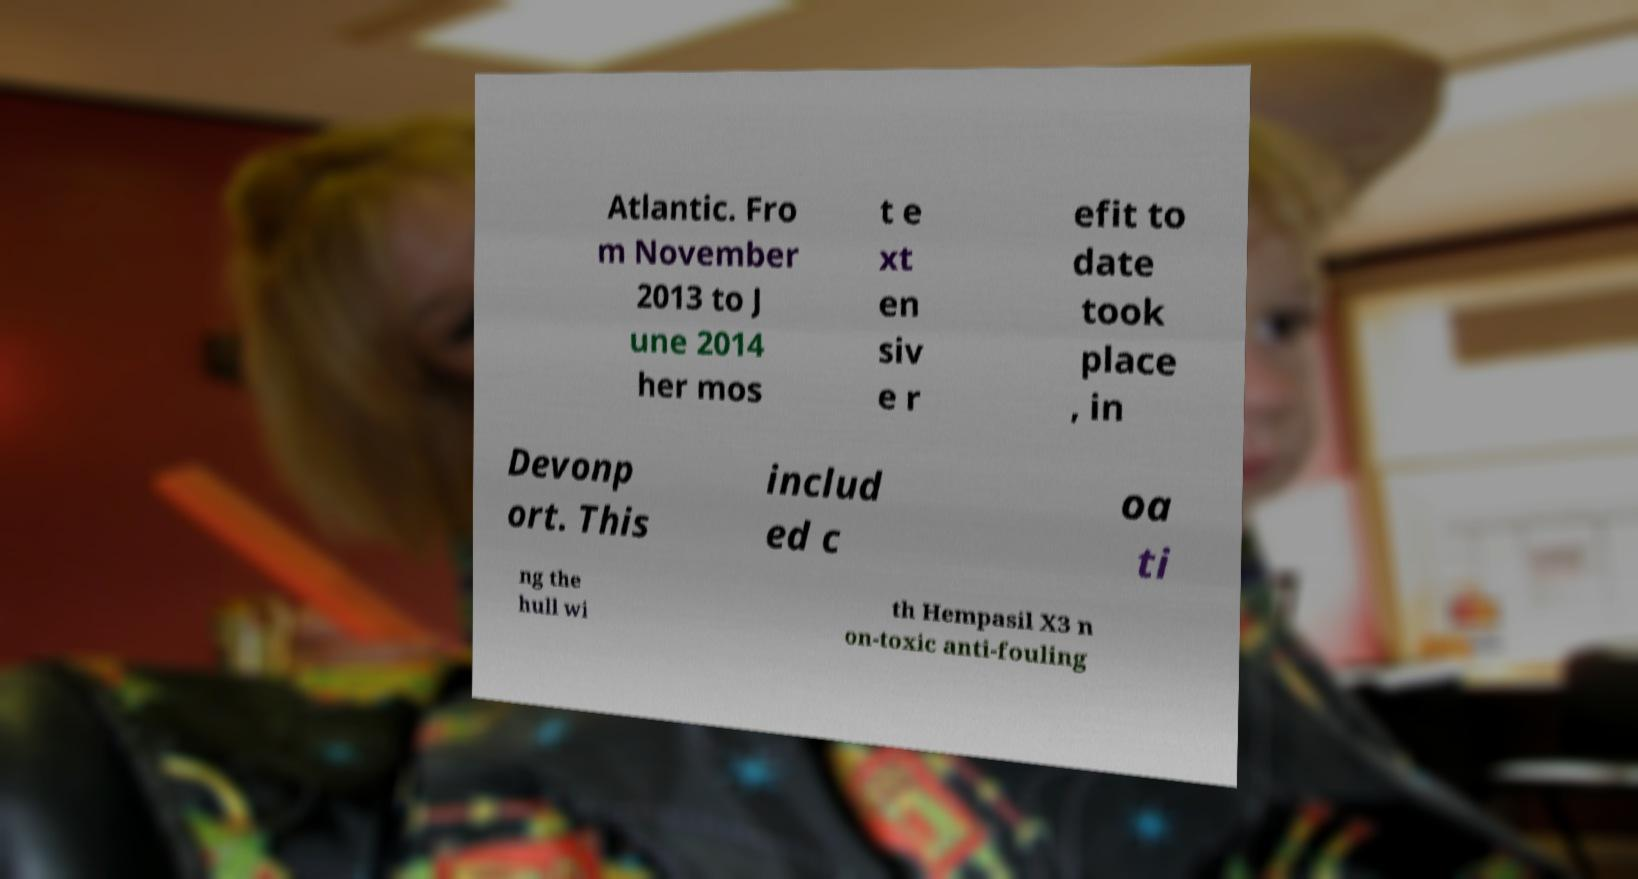I need the written content from this picture converted into text. Can you do that? Atlantic. Fro m November 2013 to J une 2014 her mos t e xt en siv e r efit to date took place , in Devonp ort. This includ ed c oa ti ng the hull wi th Hempasil X3 n on-toxic anti-fouling 